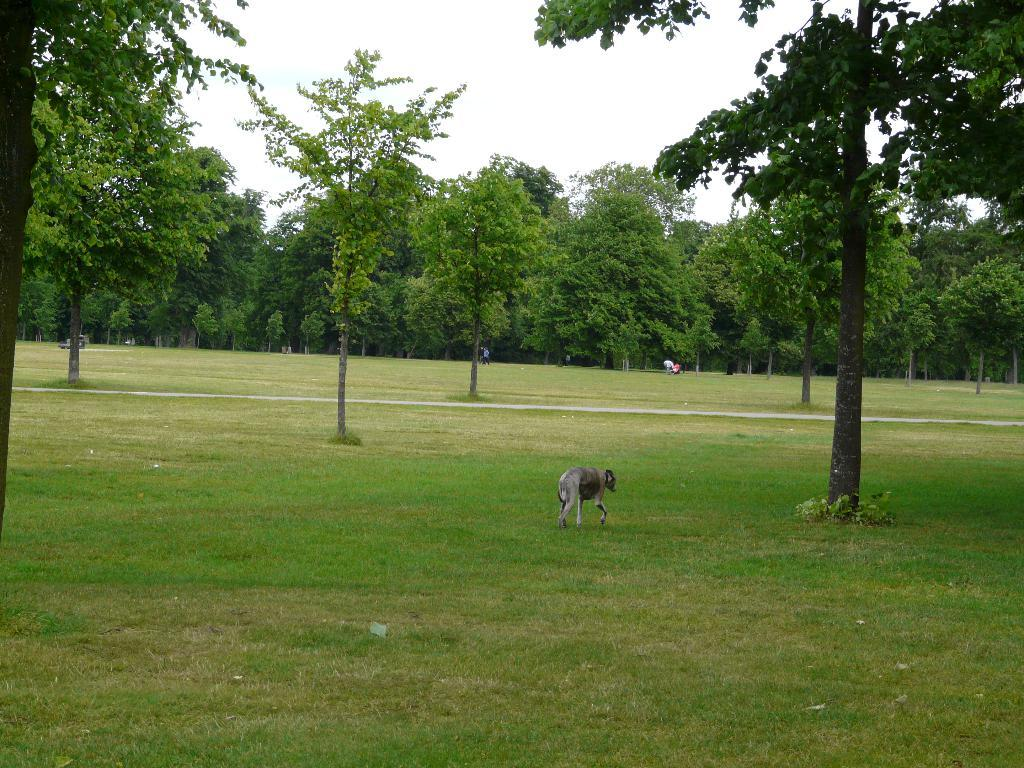What type of animal can be seen in the image? There is an animal in the image, but its specific type cannot be determined from the provided facts. What is the animal doing in the image? The animal is walking on the grassland. What can be seen in the background of the image? There are people, trees, and the sky visible in the background of the image. How many clocks are hanging from the trees in the image? There is no mention of clocks in the image, so it cannot be determined if any are present or hanging from the trees. 